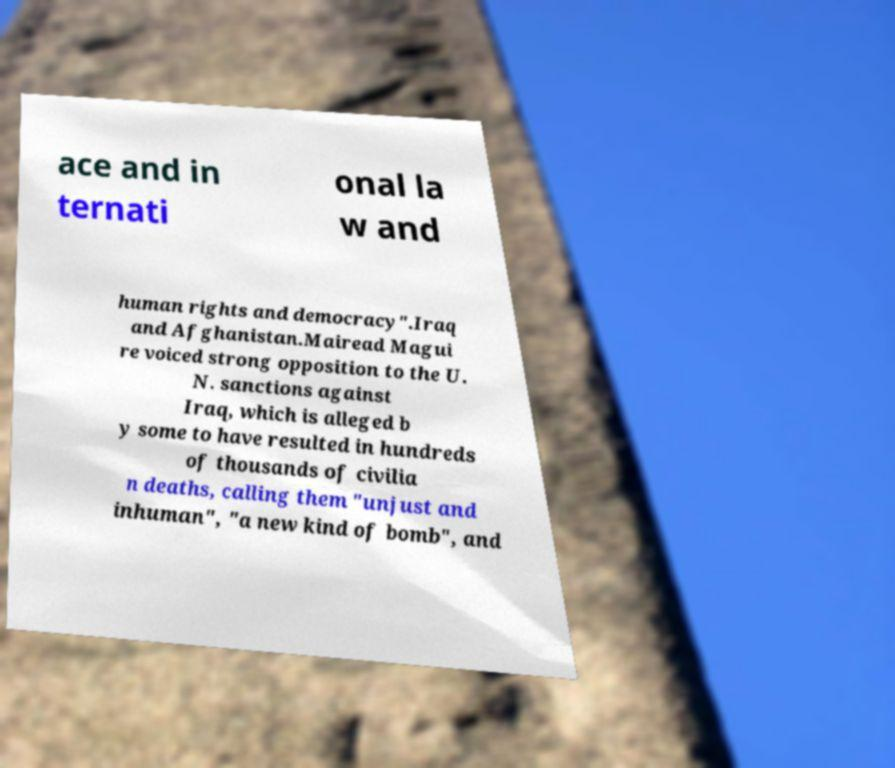Please read and relay the text visible in this image. What does it say? ace and in ternati onal la w and human rights and democracy".Iraq and Afghanistan.Mairead Magui re voiced strong opposition to the U. N. sanctions against Iraq, which is alleged b y some to have resulted in hundreds of thousands of civilia n deaths, calling them "unjust and inhuman", "a new kind of bomb", and 